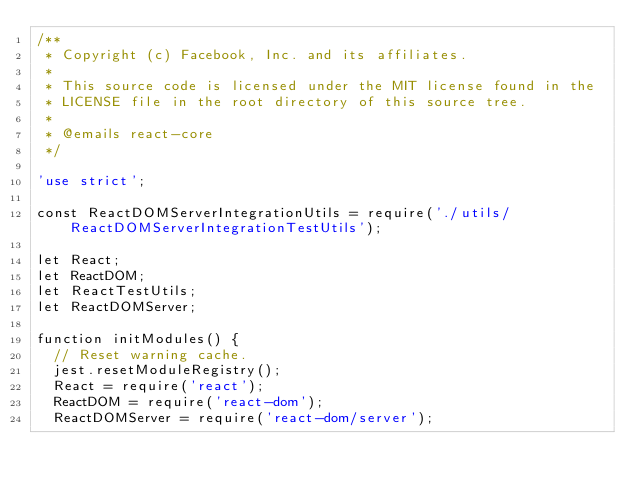<code> <loc_0><loc_0><loc_500><loc_500><_JavaScript_>/**
 * Copyright (c) Facebook, Inc. and its affiliates.
 *
 * This source code is licensed under the MIT license found in the
 * LICENSE file in the root directory of this source tree.
 *
 * @emails react-core
 */

'use strict';

const ReactDOMServerIntegrationUtils = require('./utils/ReactDOMServerIntegrationTestUtils');

let React;
let ReactDOM;
let ReactTestUtils;
let ReactDOMServer;

function initModules() {
  // Reset warning cache.
  jest.resetModuleRegistry();
  React = require('react');
  ReactDOM = require('react-dom');
  ReactDOMServer = require('react-dom/server');</code> 